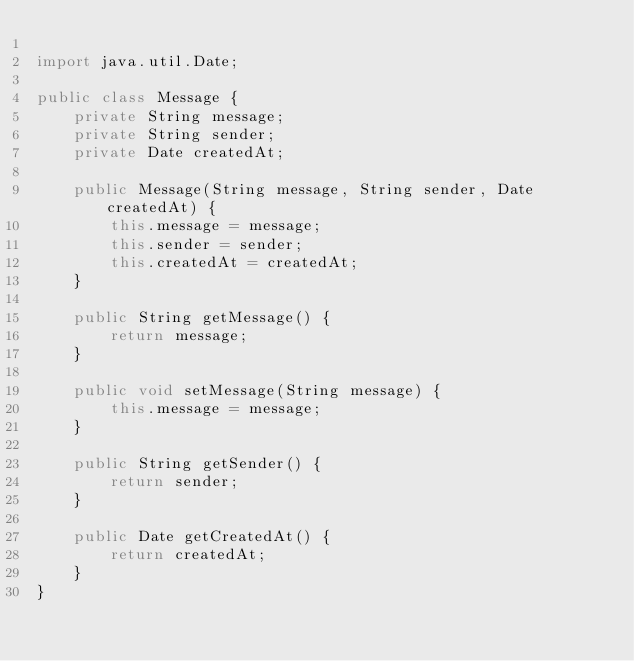Convert code to text. <code><loc_0><loc_0><loc_500><loc_500><_Java_>
import java.util.Date;

public class Message {
    private String message;
    private String sender;
    private Date createdAt;

    public Message(String message, String sender, Date createdAt) {
        this.message = message;
        this.sender = sender;
        this.createdAt = createdAt;
    }

    public String getMessage() {
        return message;
    }

    public void setMessage(String message) {
        this.message = message;
    }

    public String getSender() {
        return sender;
    }

    public Date getCreatedAt() {
        return createdAt;
    }
}</code> 